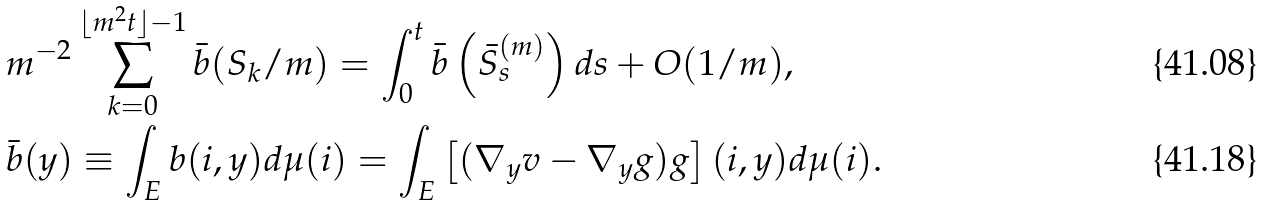Convert formula to latex. <formula><loc_0><loc_0><loc_500><loc_500>& m ^ { - 2 } \sum _ { k = 0 } ^ { \lfloor m ^ { 2 } t \rfloor - 1 } \bar { b } ( S _ { k } / m ) = \int _ { 0 } ^ { t } \bar { b } \left ( \bar { S } ^ { ( m ) } _ { s } \right ) d s + O ( 1 / m ) , \\ & \bar { b } ( y ) \equiv \int _ { E } b ( i , y ) d \mu ( i ) = \int _ { E } \left [ ( \nabla _ { y } v - \nabla _ { y } g ) g \right ] ( i , y ) d \mu ( i ) .</formula> 